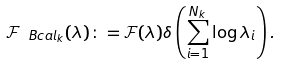Convert formula to latex. <formula><loc_0><loc_0><loc_500><loc_500>\mathcal { F } _ { \ B c a l _ { k } } ( \lambda ) \colon = \mathcal { F } ( \lambda ) \delta \left ( \sum _ { i = 1 } ^ { N _ { k } } \log \lambda _ { i } \right ) .</formula> 